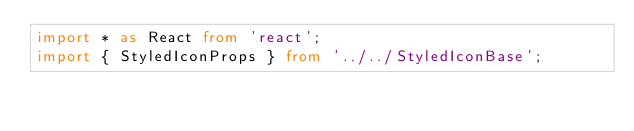<code> <loc_0><loc_0><loc_500><loc_500><_TypeScript_>import * as React from 'react';
import { StyledIconProps } from '../../StyledIconBase';</code> 